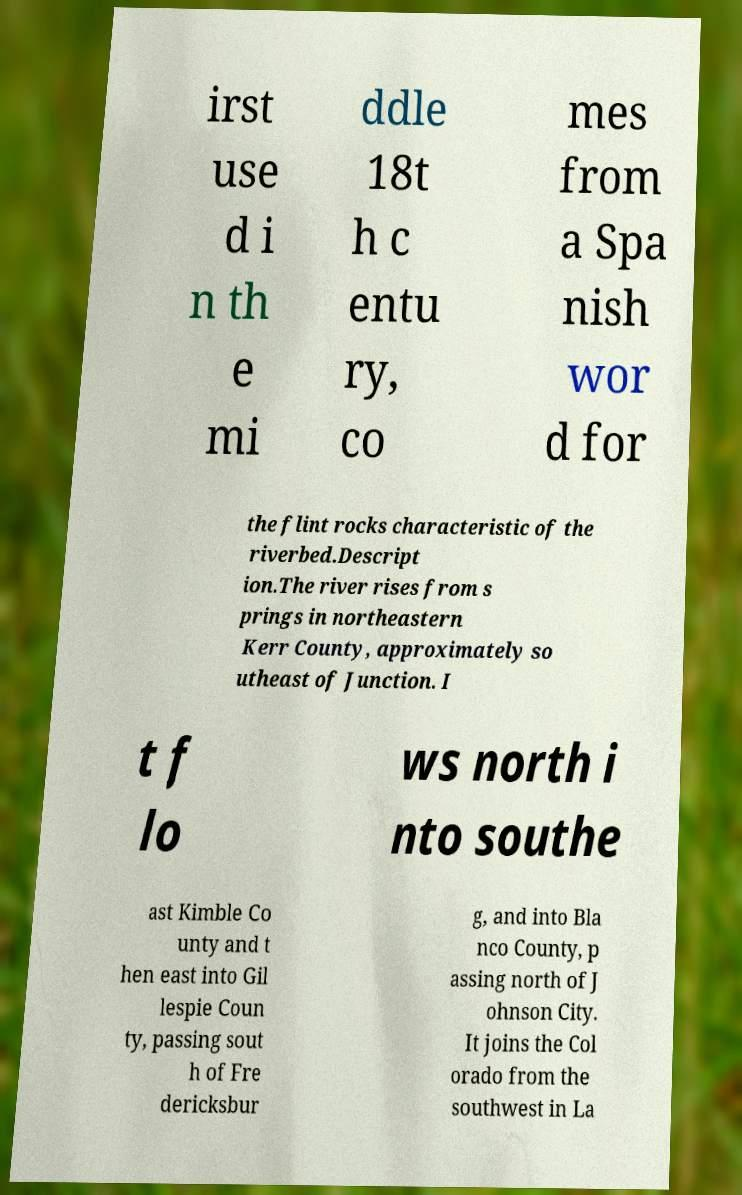Could you assist in decoding the text presented in this image and type it out clearly? irst use d i n th e mi ddle 18t h c entu ry, co mes from a Spa nish wor d for the flint rocks characteristic of the riverbed.Descript ion.The river rises from s prings in northeastern Kerr County, approximately so utheast of Junction. I t f lo ws north i nto southe ast Kimble Co unty and t hen east into Gil lespie Coun ty, passing sout h of Fre dericksbur g, and into Bla nco County, p assing north of J ohnson City. It joins the Col orado from the southwest in La 